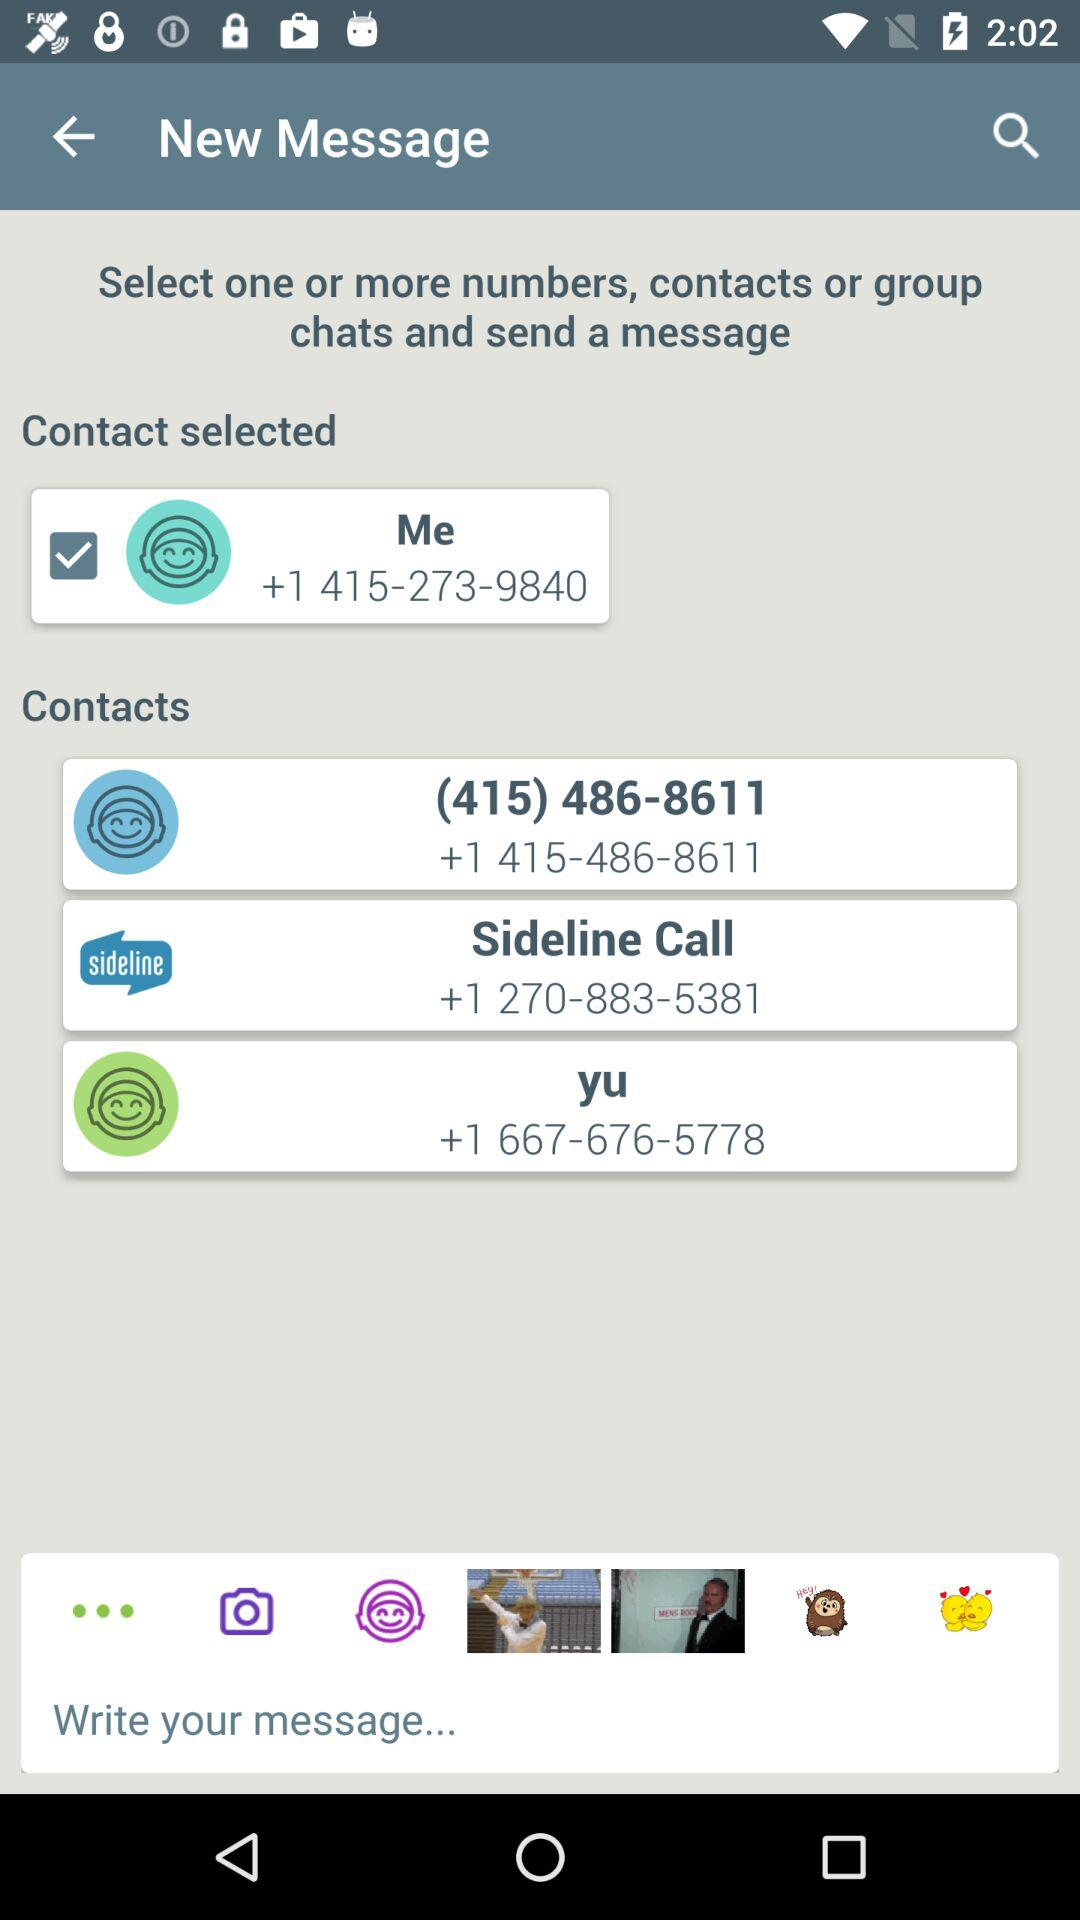How many words did the user type into their message?
When the provided information is insufficient, respond with <no answer>. <no answer> 